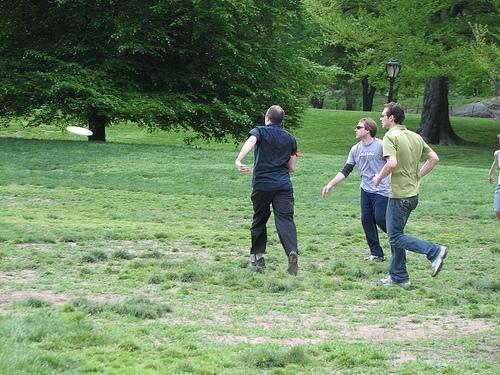How many men are in the photo?
Give a very brief answer. 3. 